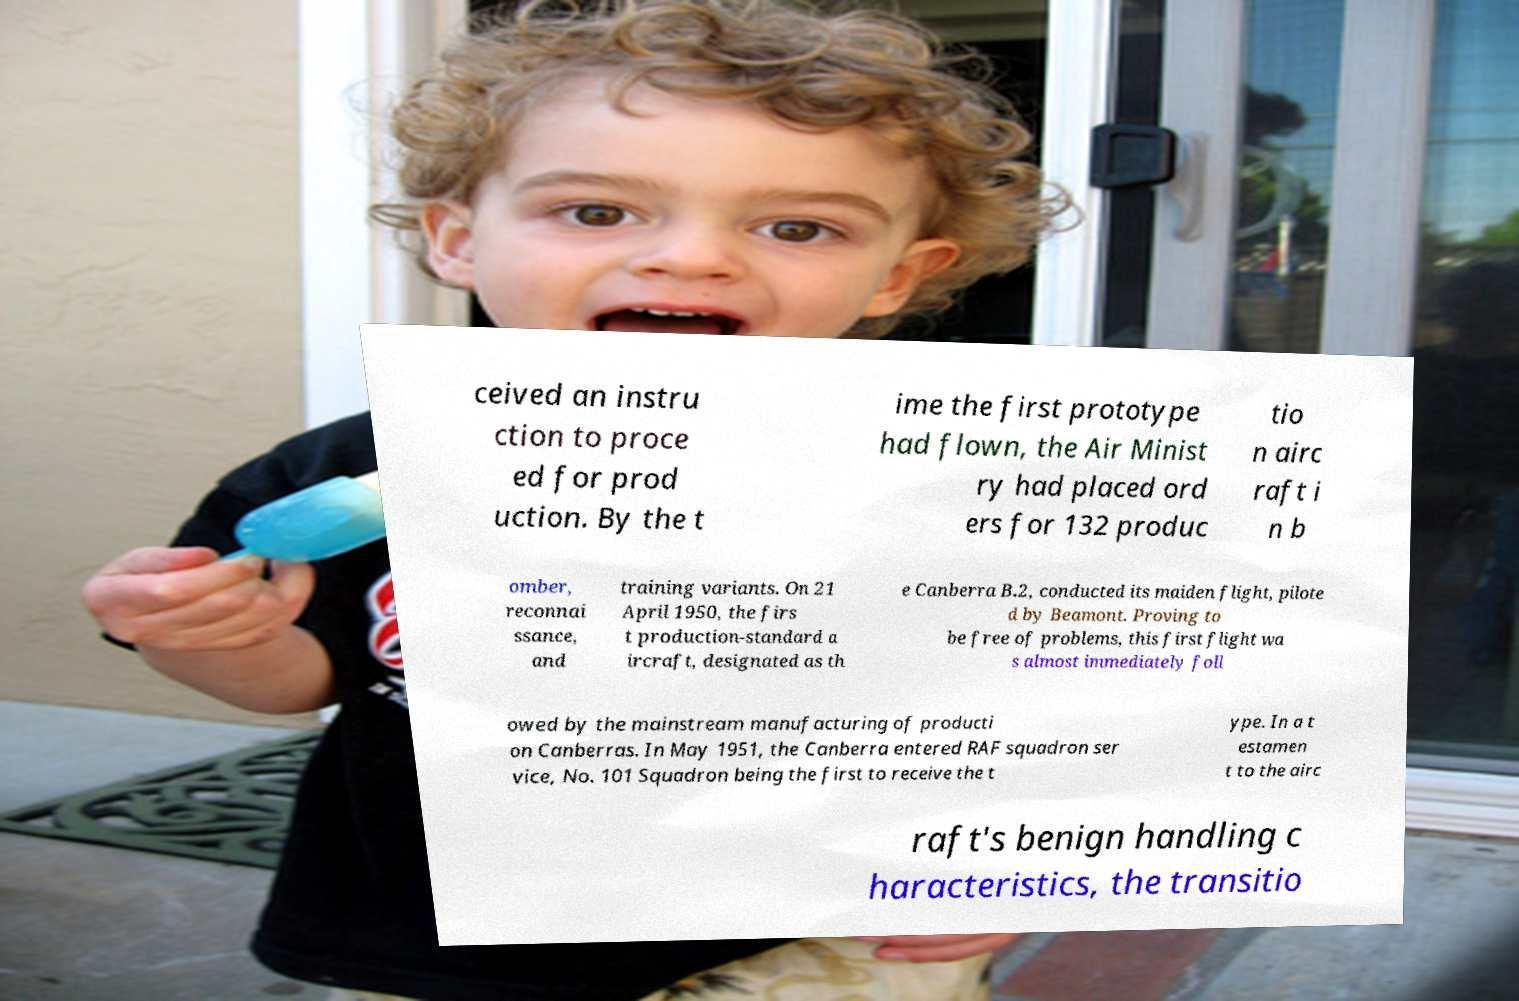Can you accurately transcribe the text from the provided image for me? ceived an instru ction to proce ed for prod uction. By the t ime the first prototype had flown, the Air Minist ry had placed ord ers for 132 produc tio n airc raft i n b omber, reconnai ssance, and training variants. On 21 April 1950, the firs t production-standard a ircraft, designated as th e Canberra B.2, conducted its maiden flight, pilote d by Beamont. Proving to be free of problems, this first flight wa s almost immediately foll owed by the mainstream manufacturing of producti on Canberras. In May 1951, the Canberra entered RAF squadron ser vice, No. 101 Squadron being the first to receive the t ype. In a t estamen t to the airc raft's benign handling c haracteristics, the transitio 